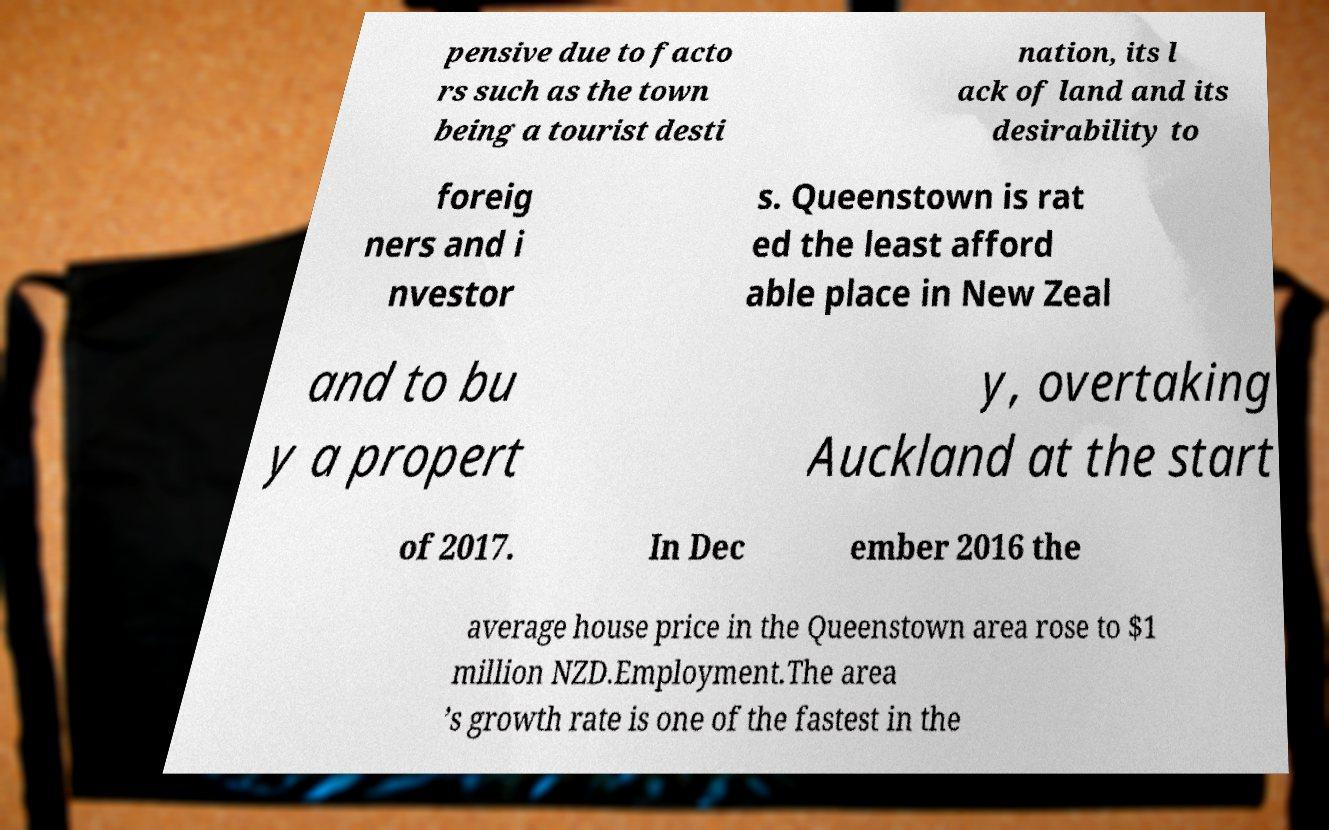There's text embedded in this image that I need extracted. Can you transcribe it verbatim? pensive due to facto rs such as the town being a tourist desti nation, its l ack of land and its desirability to foreig ners and i nvestor s. Queenstown is rat ed the least afford able place in New Zeal and to bu y a propert y, overtaking Auckland at the start of 2017. In Dec ember 2016 the average house price in the Queenstown area rose to $1 million NZD.Employment.The area ’s growth rate is one of the fastest in the 